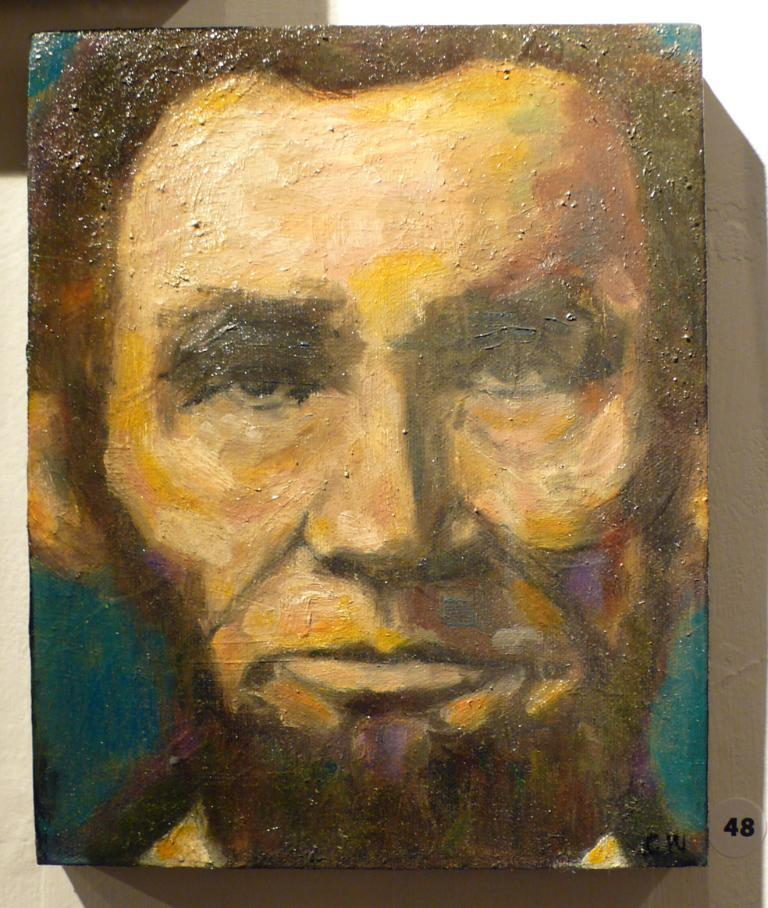What is depicted in the painting in the image? There is a painting of a person in the image. Can you identify any other elements in the image besides the painting? Yes, there is a number visible in the image. How many cakes are being served in the low battle depicted in the image? There is no depiction of cakes, a low battle, or any battle in the image. The image only contains a painting of a person and a visible number. 